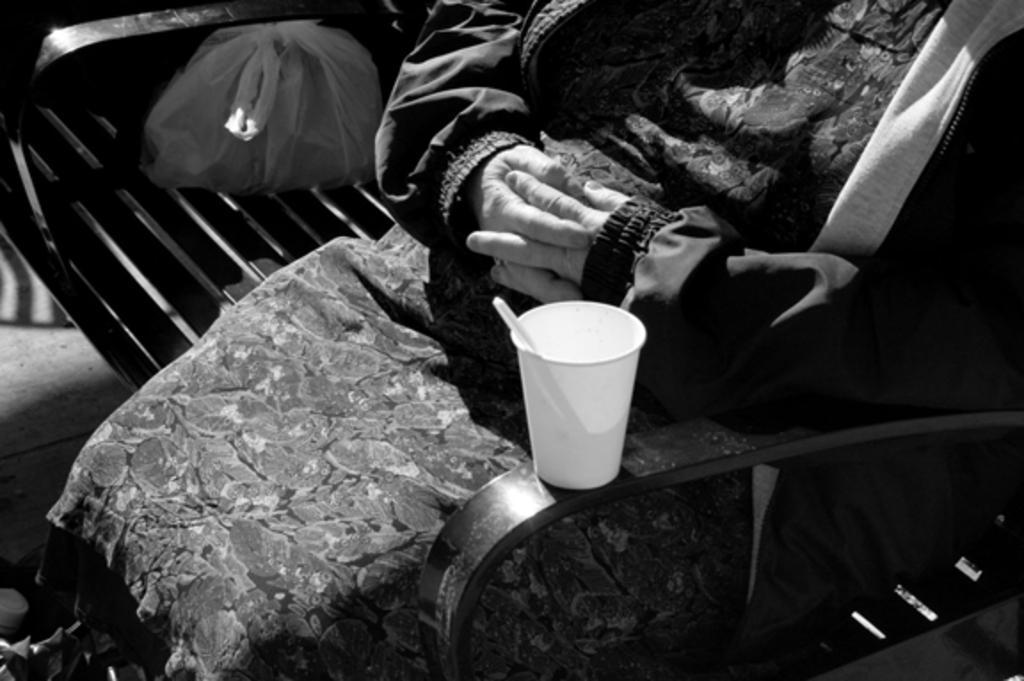Can you describe this image briefly? This is a black and white image, we can see a person sitting on a bench. We can see a glass with an object placed on the hand rest of a bench. At the top of the image, we can see a carry bag on the bench. On the left side of the image, we can see the surface and a few objects. 